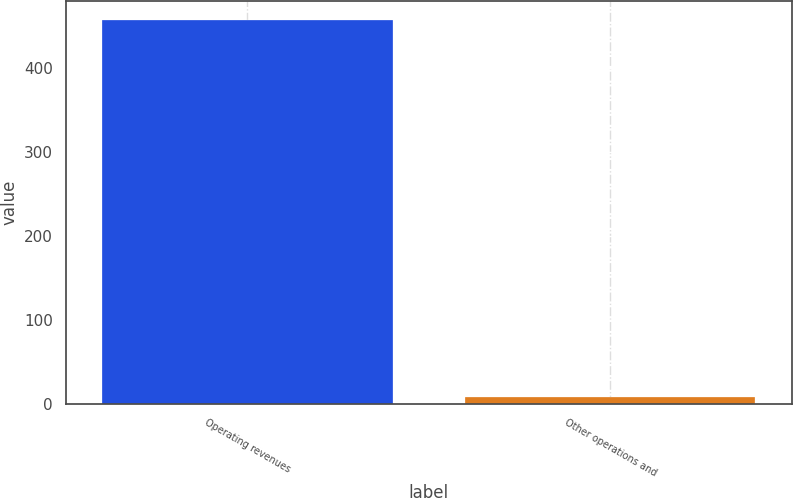Convert chart. <chart><loc_0><loc_0><loc_500><loc_500><bar_chart><fcel>Operating revenues<fcel>Other operations and<nl><fcel>458<fcel>8<nl></chart> 